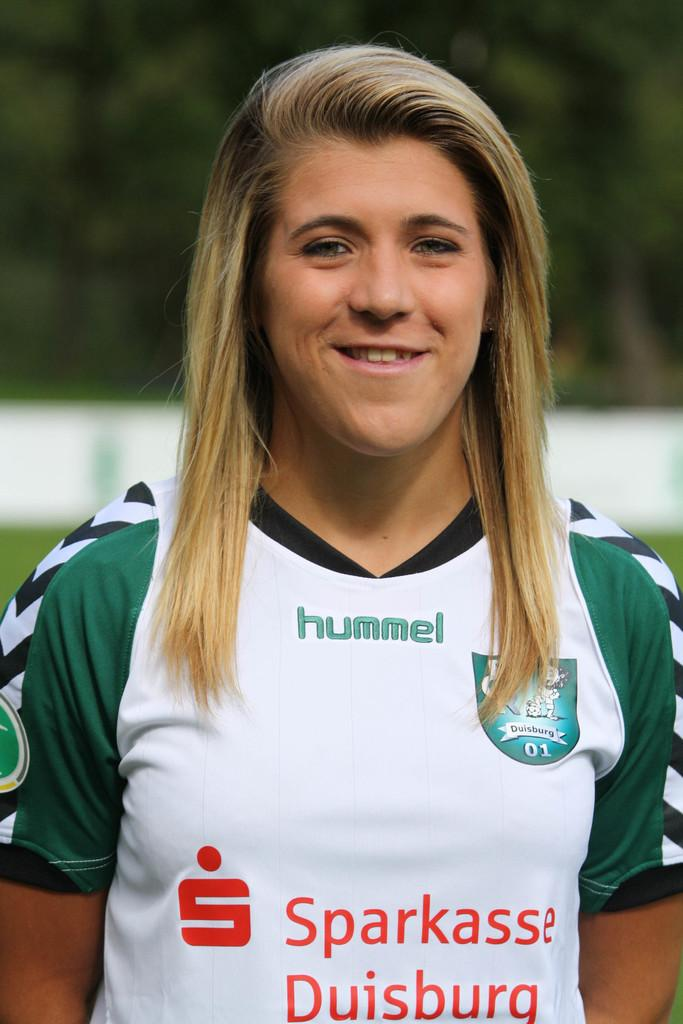<image>
Write a terse but informative summary of the picture. A woman in a shirt that says Sparkasse Duisburg. 